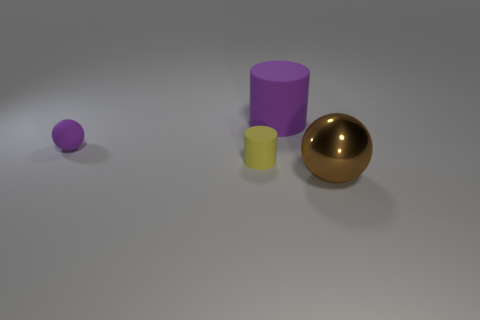Are there any purple objects?
Provide a short and direct response. Yes. What is the color of the tiny rubber object to the left of the matte cylinder on the left side of the purple rubber thing that is right of the yellow cylinder?
Keep it short and to the point. Purple. Are there the same number of cylinders that are to the right of the purple matte cylinder and yellow things to the left of the tiny rubber cylinder?
Give a very brief answer. Yes. There is a purple rubber object that is the same size as the metal thing; what shape is it?
Provide a short and direct response. Cylinder. Are there any other tiny balls of the same color as the tiny sphere?
Offer a very short reply. No. What is the shape of the thing to the right of the big matte cylinder?
Ensure brevity in your answer.  Sphere. What is the color of the large cylinder?
Your answer should be very brief. Purple. There is a tiny object that is the same material as the yellow cylinder; what color is it?
Offer a very short reply. Purple. What number of big brown spheres have the same material as the yellow thing?
Keep it short and to the point. 0. How many tiny balls are in front of the purple ball?
Your answer should be very brief. 0. 